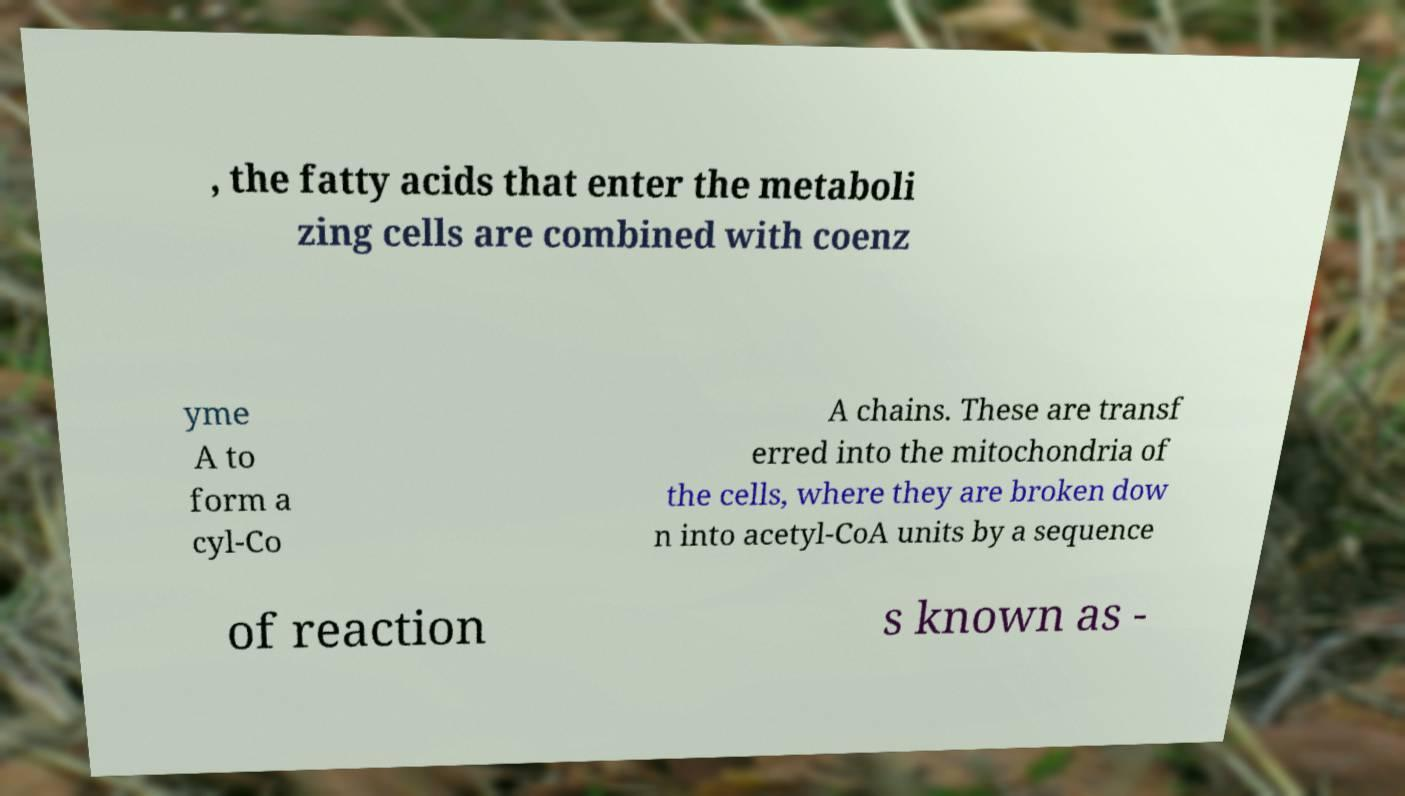Can you accurately transcribe the text from the provided image for me? , the fatty acids that enter the metaboli zing cells are combined with coenz yme A to form a cyl-Co A chains. These are transf erred into the mitochondria of the cells, where they are broken dow n into acetyl-CoA units by a sequence of reaction s known as - 